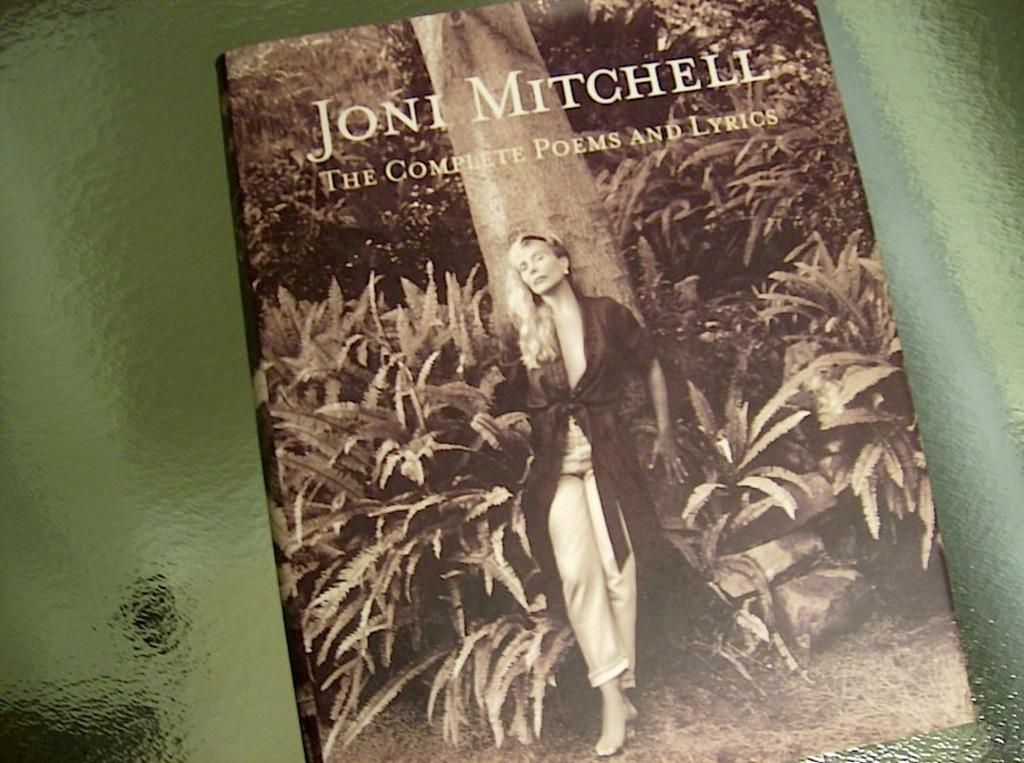What type of literature does this book contain?
Ensure brevity in your answer.  Poems and lyrics. 